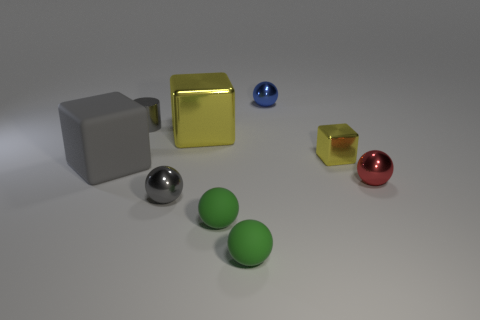Subtract all big blocks. How many blocks are left? 1 Subtract all cylinders. How many objects are left? 8 Subtract all yellow blocks. How many blocks are left? 1 Subtract all brown cubes. How many green balls are left? 2 Subtract 1 cylinders. How many cylinders are left? 0 Subtract all small metallic cubes. Subtract all tiny gray cylinders. How many objects are left? 7 Add 2 big gray blocks. How many big gray blocks are left? 3 Add 9 big yellow rubber cylinders. How many big yellow rubber cylinders exist? 9 Subtract 0 cyan spheres. How many objects are left? 9 Subtract all cyan balls. Subtract all yellow cylinders. How many balls are left? 5 